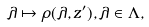<formula> <loc_0><loc_0><loc_500><loc_500>\lambda \mapsto \rho ( \lambda , z ^ { \prime } ) , \lambda \in \Lambda ,</formula> 